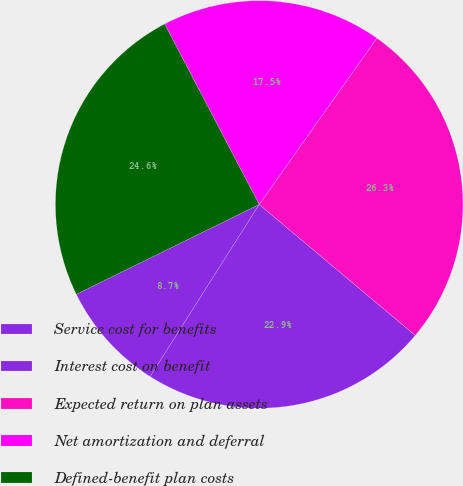Convert chart. <chart><loc_0><loc_0><loc_500><loc_500><pie_chart><fcel>Service cost for benefits<fcel>Interest cost on benefit<fcel>Expected return on plan assets<fcel>Net amortization and deferral<fcel>Defined-benefit plan costs<nl><fcel>8.74%<fcel>22.88%<fcel>26.31%<fcel>17.48%<fcel>24.59%<nl></chart> 